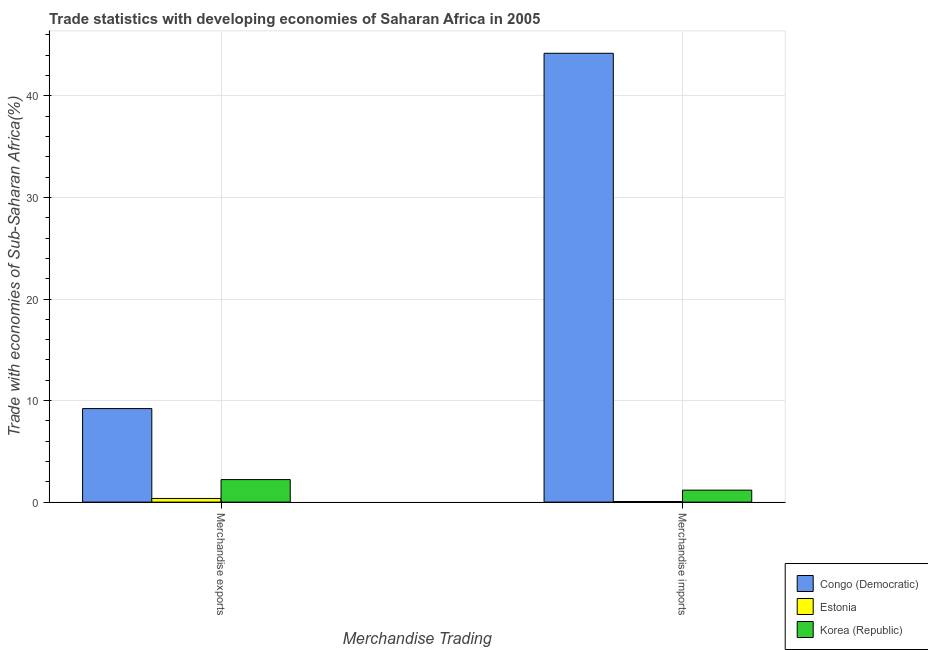How many different coloured bars are there?
Provide a short and direct response. 3. How many groups of bars are there?
Keep it short and to the point. 2. Are the number of bars per tick equal to the number of legend labels?
Give a very brief answer. Yes. What is the label of the 2nd group of bars from the left?
Offer a terse response. Merchandise imports. What is the merchandise exports in Congo (Democratic)?
Your response must be concise. 9.21. Across all countries, what is the maximum merchandise exports?
Make the answer very short. 9.21. Across all countries, what is the minimum merchandise exports?
Your answer should be compact. 0.36. In which country was the merchandise exports maximum?
Your answer should be very brief. Congo (Democratic). In which country was the merchandise imports minimum?
Your answer should be very brief. Estonia. What is the total merchandise imports in the graph?
Offer a terse response. 45.44. What is the difference between the merchandise exports in Korea (Republic) and that in Estonia?
Provide a short and direct response. 1.86. What is the difference between the merchandise imports in Estonia and the merchandise exports in Korea (Republic)?
Keep it short and to the point. -2.16. What is the average merchandise imports per country?
Offer a very short reply. 15.15. What is the difference between the merchandise exports and merchandise imports in Congo (Democratic)?
Provide a succinct answer. -34.99. What is the ratio of the merchandise exports in Estonia to that in Korea (Republic)?
Give a very brief answer. 0.16. In how many countries, is the merchandise exports greater than the average merchandise exports taken over all countries?
Make the answer very short. 1. What does the 2nd bar from the left in Merchandise imports represents?
Provide a short and direct response. Estonia. What does the 3rd bar from the right in Merchandise exports represents?
Keep it short and to the point. Congo (Democratic). Are all the bars in the graph horizontal?
Make the answer very short. No. How many countries are there in the graph?
Keep it short and to the point. 3. What is the difference between two consecutive major ticks on the Y-axis?
Make the answer very short. 10. Are the values on the major ticks of Y-axis written in scientific E-notation?
Your answer should be compact. No. Does the graph contain any zero values?
Your answer should be compact. No. Does the graph contain grids?
Provide a short and direct response. Yes. How many legend labels are there?
Provide a short and direct response. 3. How are the legend labels stacked?
Provide a succinct answer. Vertical. What is the title of the graph?
Your answer should be very brief. Trade statistics with developing economies of Saharan Africa in 2005. What is the label or title of the X-axis?
Offer a very short reply. Merchandise Trading. What is the label or title of the Y-axis?
Keep it short and to the point. Trade with economies of Sub-Saharan Africa(%). What is the Trade with economies of Sub-Saharan Africa(%) of Congo (Democratic) in Merchandise exports?
Keep it short and to the point. 9.21. What is the Trade with economies of Sub-Saharan Africa(%) in Estonia in Merchandise exports?
Your answer should be very brief. 0.36. What is the Trade with economies of Sub-Saharan Africa(%) in Korea (Republic) in Merchandise exports?
Give a very brief answer. 2.22. What is the Trade with economies of Sub-Saharan Africa(%) in Congo (Democratic) in Merchandise imports?
Give a very brief answer. 44.2. What is the Trade with economies of Sub-Saharan Africa(%) of Estonia in Merchandise imports?
Make the answer very short. 0.06. What is the Trade with economies of Sub-Saharan Africa(%) in Korea (Republic) in Merchandise imports?
Ensure brevity in your answer.  1.18. Across all Merchandise Trading, what is the maximum Trade with economies of Sub-Saharan Africa(%) in Congo (Democratic)?
Provide a succinct answer. 44.2. Across all Merchandise Trading, what is the maximum Trade with economies of Sub-Saharan Africa(%) of Estonia?
Keep it short and to the point. 0.36. Across all Merchandise Trading, what is the maximum Trade with economies of Sub-Saharan Africa(%) in Korea (Republic)?
Ensure brevity in your answer.  2.22. Across all Merchandise Trading, what is the minimum Trade with economies of Sub-Saharan Africa(%) in Congo (Democratic)?
Your response must be concise. 9.21. Across all Merchandise Trading, what is the minimum Trade with economies of Sub-Saharan Africa(%) of Estonia?
Offer a terse response. 0.06. Across all Merchandise Trading, what is the minimum Trade with economies of Sub-Saharan Africa(%) in Korea (Republic)?
Your answer should be very brief. 1.18. What is the total Trade with economies of Sub-Saharan Africa(%) in Congo (Democratic) in the graph?
Provide a succinct answer. 53.41. What is the total Trade with economies of Sub-Saharan Africa(%) in Estonia in the graph?
Ensure brevity in your answer.  0.42. What is the difference between the Trade with economies of Sub-Saharan Africa(%) of Congo (Democratic) in Merchandise exports and that in Merchandise imports?
Provide a succinct answer. -34.99. What is the difference between the Trade with economies of Sub-Saharan Africa(%) of Estonia in Merchandise exports and that in Merchandise imports?
Your answer should be very brief. 0.3. What is the difference between the Trade with economies of Sub-Saharan Africa(%) of Korea (Republic) in Merchandise exports and that in Merchandise imports?
Your response must be concise. 1.04. What is the difference between the Trade with economies of Sub-Saharan Africa(%) in Congo (Democratic) in Merchandise exports and the Trade with economies of Sub-Saharan Africa(%) in Estonia in Merchandise imports?
Your answer should be compact. 9.15. What is the difference between the Trade with economies of Sub-Saharan Africa(%) in Congo (Democratic) in Merchandise exports and the Trade with economies of Sub-Saharan Africa(%) in Korea (Republic) in Merchandise imports?
Offer a very short reply. 8.03. What is the difference between the Trade with economies of Sub-Saharan Africa(%) in Estonia in Merchandise exports and the Trade with economies of Sub-Saharan Africa(%) in Korea (Republic) in Merchandise imports?
Your response must be concise. -0.82. What is the average Trade with economies of Sub-Saharan Africa(%) of Congo (Democratic) per Merchandise Trading?
Make the answer very short. 26.7. What is the average Trade with economies of Sub-Saharan Africa(%) of Estonia per Merchandise Trading?
Offer a terse response. 0.21. What is the difference between the Trade with economies of Sub-Saharan Africa(%) in Congo (Democratic) and Trade with economies of Sub-Saharan Africa(%) in Estonia in Merchandise exports?
Ensure brevity in your answer.  8.85. What is the difference between the Trade with economies of Sub-Saharan Africa(%) of Congo (Democratic) and Trade with economies of Sub-Saharan Africa(%) of Korea (Republic) in Merchandise exports?
Ensure brevity in your answer.  6.99. What is the difference between the Trade with economies of Sub-Saharan Africa(%) of Estonia and Trade with economies of Sub-Saharan Africa(%) of Korea (Republic) in Merchandise exports?
Provide a short and direct response. -1.86. What is the difference between the Trade with economies of Sub-Saharan Africa(%) in Congo (Democratic) and Trade with economies of Sub-Saharan Africa(%) in Estonia in Merchandise imports?
Provide a short and direct response. 44.14. What is the difference between the Trade with economies of Sub-Saharan Africa(%) in Congo (Democratic) and Trade with economies of Sub-Saharan Africa(%) in Korea (Republic) in Merchandise imports?
Make the answer very short. 43.02. What is the difference between the Trade with economies of Sub-Saharan Africa(%) of Estonia and Trade with economies of Sub-Saharan Africa(%) of Korea (Republic) in Merchandise imports?
Provide a short and direct response. -1.12. What is the ratio of the Trade with economies of Sub-Saharan Africa(%) of Congo (Democratic) in Merchandise exports to that in Merchandise imports?
Keep it short and to the point. 0.21. What is the ratio of the Trade with economies of Sub-Saharan Africa(%) in Estonia in Merchandise exports to that in Merchandise imports?
Provide a succinct answer. 5.97. What is the ratio of the Trade with economies of Sub-Saharan Africa(%) of Korea (Republic) in Merchandise exports to that in Merchandise imports?
Offer a very short reply. 1.88. What is the difference between the highest and the second highest Trade with economies of Sub-Saharan Africa(%) in Congo (Democratic)?
Keep it short and to the point. 34.99. What is the difference between the highest and the second highest Trade with economies of Sub-Saharan Africa(%) in Estonia?
Provide a short and direct response. 0.3. What is the difference between the highest and the second highest Trade with economies of Sub-Saharan Africa(%) of Korea (Republic)?
Provide a succinct answer. 1.04. What is the difference between the highest and the lowest Trade with economies of Sub-Saharan Africa(%) of Congo (Democratic)?
Your response must be concise. 34.99. What is the difference between the highest and the lowest Trade with economies of Sub-Saharan Africa(%) of Estonia?
Provide a succinct answer. 0.3. What is the difference between the highest and the lowest Trade with economies of Sub-Saharan Africa(%) of Korea (Republic)?
Give a very brief answer. 1.04. 